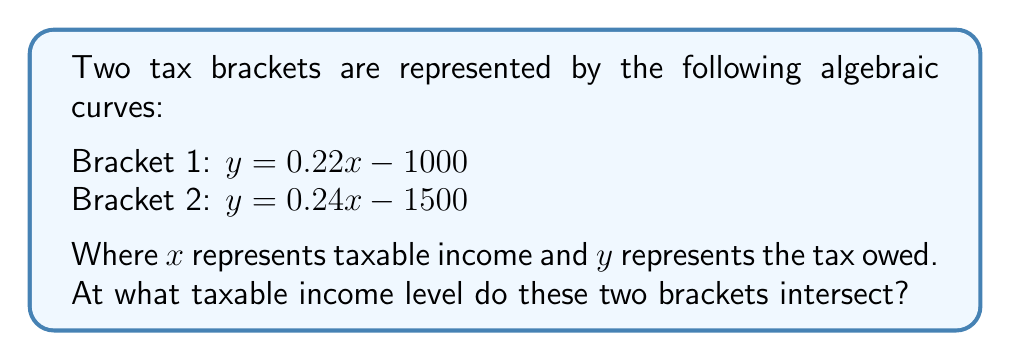Teach me how to tackle this problem. To find the intersection of these two tax bracket curves, we need to solve the equation where both curves are equal:

1. Set the equations equal to each other:
   $0.22x - 1000 = 0.24x - 1500$

2. Subtract $0.22x$ from both sides:
   $-1000 = 0.02x - 1500$

3. Add 1500 to both sides:
   $500 = 0.02x$

4. Divide both sides by 0.02:
   $25000 = x$

5. Check the result by plugging it back into both original equations:
   For Bracket 1: $y = 0.22(25000) - 1000 = 5500 - 1000 = 4500$
   For Bracket 2: $y = 0.24(25000) - 1500 = 6000 - 1500 = 4500$

Both equations yield the same $y$ value, confirming the intersection point.
Answer: $25,000 